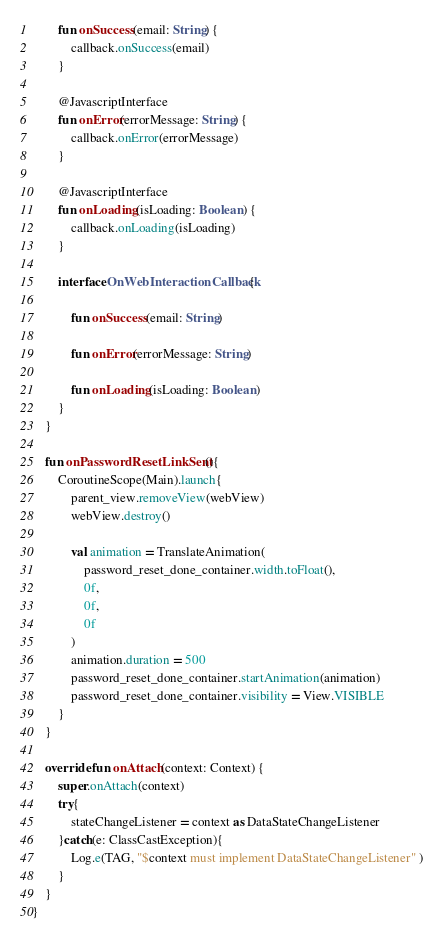Convert code to text. <code><loc_0><loc_0><loc_500><loc_500><_Kotlin_>        fun onSuccess(email: String) {
            callback.onSuccess(email)
        }

        @JavascriptInterface
        fun onError(errorMessage: String) {
            callback.onError(errorMessage)
        }

        @JavascriptInterface
        fun onLoading(isLoading: Boolean) {
            callback.onLoading(isLoading)
        }

        interface OnWebInteractionCallback{

            fun onSuccess(email: String)

            fun onError(errorMessage: String)

            fun onLoading(isLoading: Boolean)
        }
    }

    fun onPasswordResetLinkSent(){
        CoroutineScope(Main).launch{
            parent_view.removeView(webView)
            webView.destroy()

            val animation = TranslateAnimation(
                password_reset_done_container.width.toFloat(),
                0f,
                0f,
                0f
            )
            animation.duration = 500
            password_reset_done_container.startAnimation(animation)
            password_reset_done_container.visibility = View.VISIBLE
        }
    }

    override fun onAttach(context: Context) {
        super.onAttach(context)
        try{
            stateChangeListener = context as DataStateChangeListener
        }catch(e: ClassCastException){
            Log.e(TAG, "$context must implement DataStateChangeListener" )
        }
    }
}
</code> 